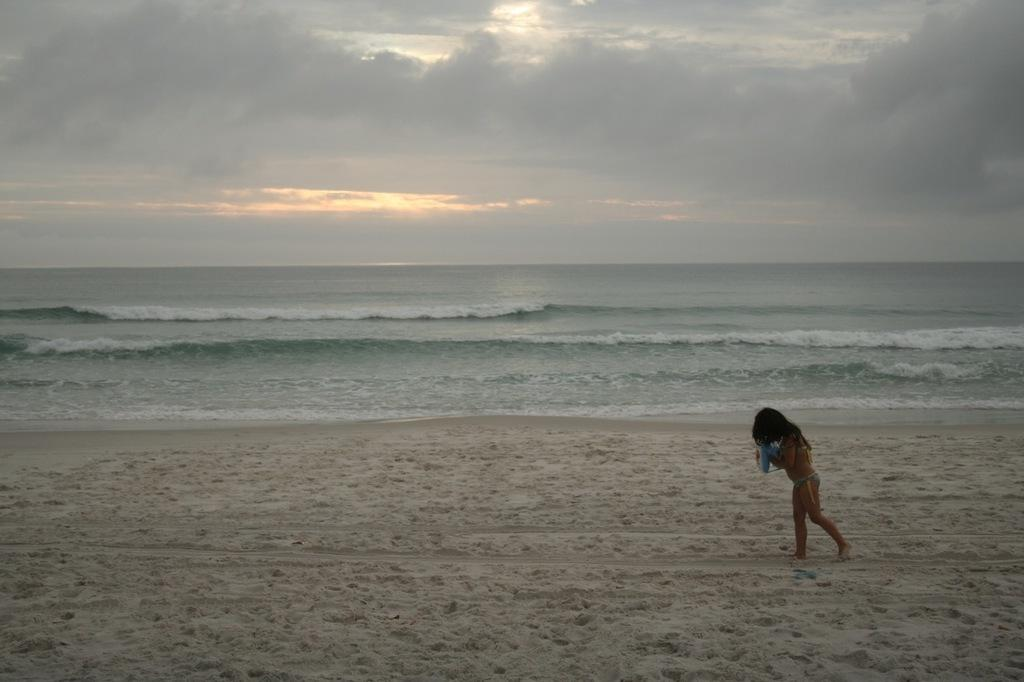What is the woman in the image doing? The woman is walking in the image. On which side of the image is the woman walking? The woman is walking on the right side. What type of terrain is visible in the image? There is sand visible in the image. What can be seen in the background of the image? There is water, clouds, and the sky visible in the background of the image. What type of detail can be seen on the woman's shoes in the image? There is no specific detail mentioned about the woman's shoes in the provided facts, so we cannot answer this question. 